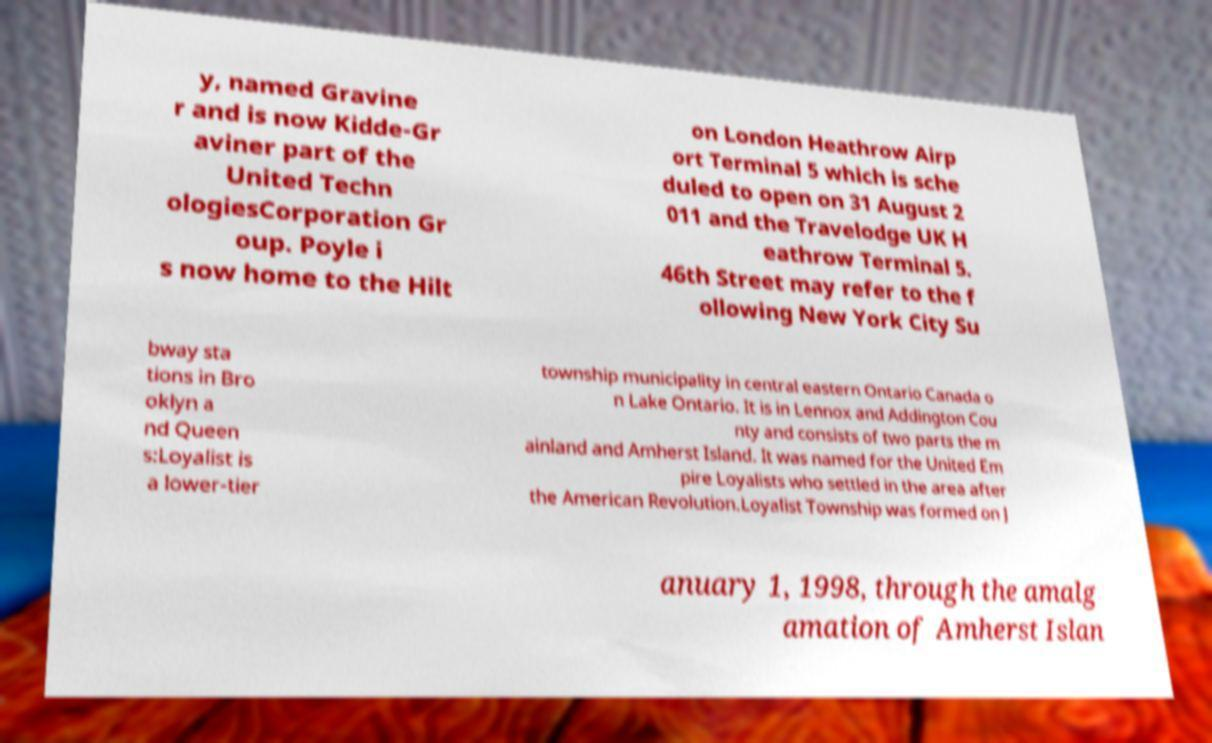Can you accurately transcribe the text from the provided image for me? y, named Gravine r and is now Kidde-Gr aviner part of the United Techn ologiesCorporation Gr oup. Poyle i s now home to the Hilt on London Heathrow Airp ort Terminal 5 which is sche duled to open on 31 August 2 011 and the Travelodge UK H eathrow Terminal 5. 46th Street may refer to the f ollowing New York City Su bway sta tions in Bro oklyn a nd Queen s:Loyalist is a lower-tier township municipality in central eastern Ontario Canada o n Lake Ontario. It is in Lennox and Addington Cou nty and consists of two parts the m ainland and Amherst Island. It was named for the United Em pire Loyalists who settled in the area after the American Revolution.Loyalist Township was formed on J anuary 1, 1998, through the amalg amation of Amherst Islan 